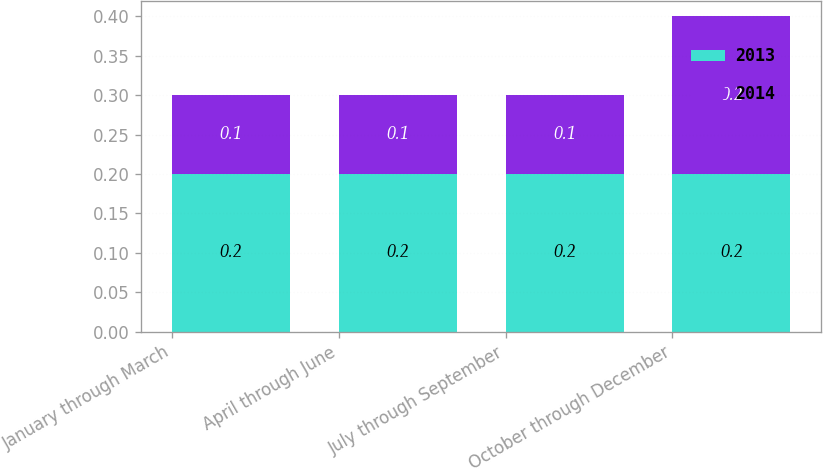<chart> <loc_0><loc_0><loc_500><loc_500><stacked_bar_chart><ecel><fcel>January through March<fcel>April through June<fcel>July through September<fcel>October through December<nl><fcel>2013<fcel>0.2<fcel>0.2<fcel>0.2<fcel>0.2<nl><fcel>2014<fcel>0.1<fcel>0.1<fcel>0.1<fcel>0.2<nl></chart> 